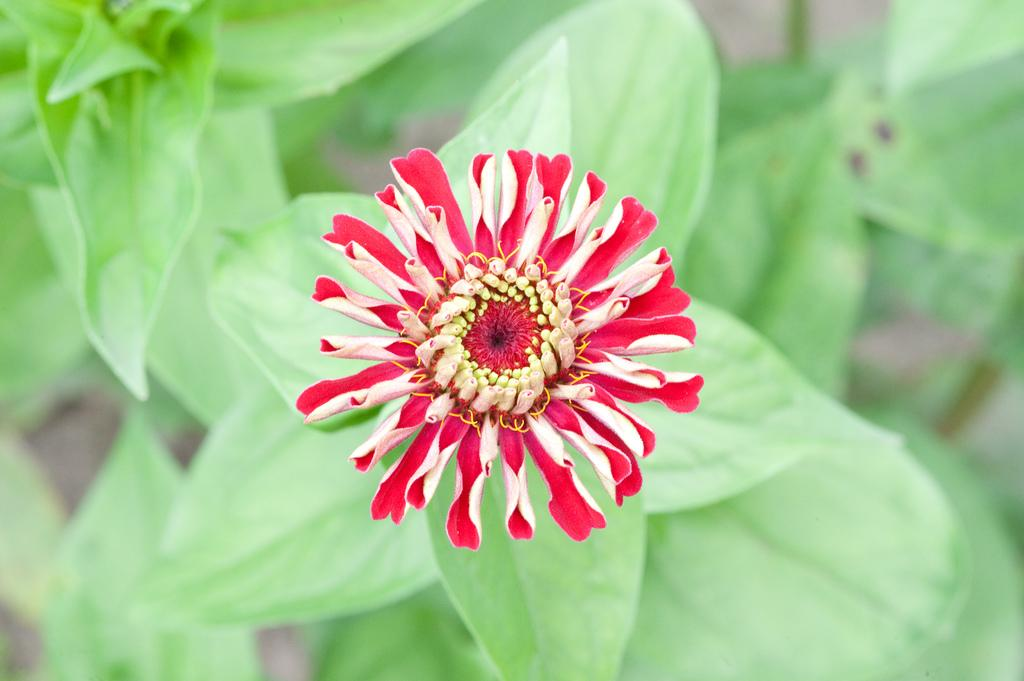What type of living organisms are present in the image? There are plants in the image. What specific features can be observed on the plants? The plants have leaves and flowers. What color are the flowers on the plants? The flowers are red in color. What structural components make up the flowers? The flowers have petals. How many elbows can be seen on the plants in the image? There are no elbows present on the plants in the image, as elbows are a human body part and not a feature of plants. 